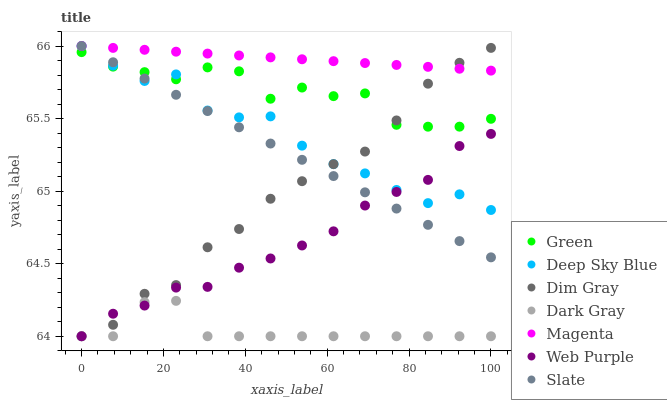Does Dark Gray have the minimum area under the curve?
Answer yes or no. Yes. Does Magenta have the maximum area under the curve?
Answer yes or no. Yes. Does Slate have the minimum area under the curve?
Answer yes or no. No. Does Slate have the maximum area under the curve?
Answer yes or no. No. Is Magenta the smoothest?
Answer yes or no. Yes. Is Deep Sky Blue the roughest?
Answer yes or no. Yes. Is Slate the smoothest?
Answer yes or no. No. Is Slate the roughest?
Answer yes or no. No. Does Dim Gray have the lowest value?
Answer yes or no. Yes. Does Slate have the lowest value?
Answer yes or no. No. Does Magenta have the highest value?
Answer yes or no. Yes. Does Dark Gray have the highest value?
Answer yes or no. No. Is Web Purple less than Magenta?
Answer yes or no. Yes. Is Magenta greater than Dark Gray?
Answer yes or no. Yes. Does Dim Gray intersect Green?
Answer yes or no. Yes. Is Dim Gray less than Green?
Answer yes or no. No. Is Dim Gray greater than Green?
Answer yes or no. No. Does Web Purple intersect Magenta?
Answer yes or no. No. 